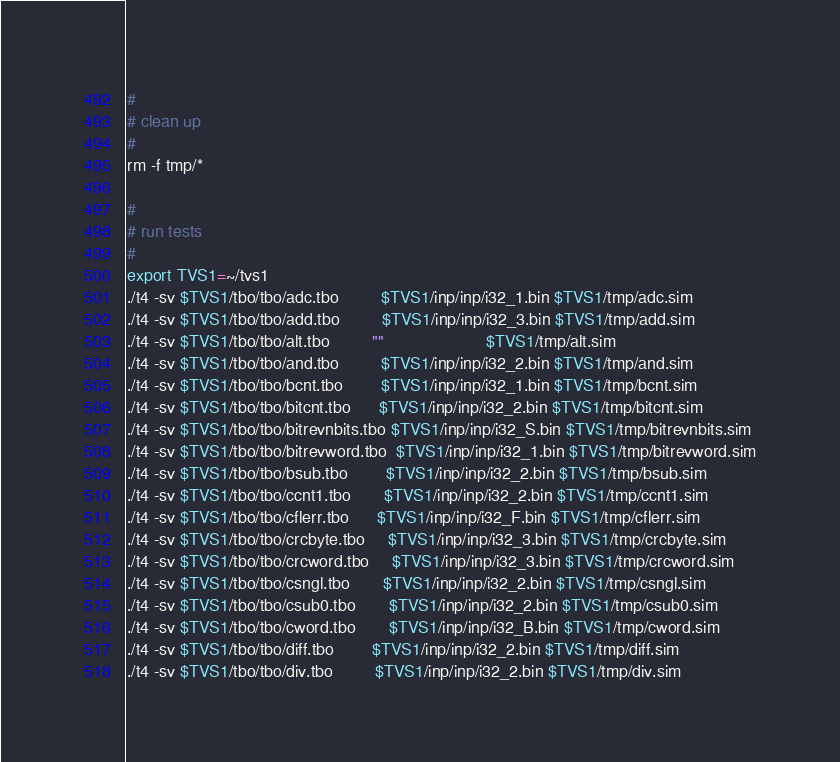<code> <loc_0><loc_0><loc_500><loc_500><_Bash_>#
# clean up
#
rm -f tmp/*

#
# run tests
#
export TVS1=~/tvs1
./t4 -sv $TVS1/tbo/tbo/adc.tbo         $TVS1/inp/inp/i32_1.bin $TVS1/tmp/adc.sim
./t4 -sv $TVS1/tbo/tbo/add.tbo         $TVS1/inp/inp/i32_3.bin $TVS1/tmp/add.sim
./t4 -sv $TVS1/tbo/tbo/alt.tbo         ""                      $TVS1/tmp/alt.sim
./t4 -sv $TVS1/tbo/tbo/and.tbo         $TVS1/inp/inp/i32_2.bin $TVS1/tmp/and.sim
./t4 -sv $TVS1/tbo/tbo/bcnt.tbo        $TVS1/inp/inp/i32_1.bin $TVS1/tmp/bcnt.sim
./t4 -sv $TVS1/tbo/tbo/bitcnt.tbo      $TVS1/inp/inp/i32_2.bin $TVS1/tmp/bitcnt.sim
./t4 -sv $TVS1/tbo/tbo/bitrevnbits.tbo $TVS1/inp/inp/i32_S.bin $TVS1/tmp/bitrevnbits.sim
./t4 -sv $TVS1/tbo/tbo/bitrevword.tbo  $TVS1/inp/inp/i32_1.bin $TVS1/tmp/bitrevword.sim
./t4 -sv $TVS1/tbo/tbo/bsub.tbo        $TVS1/inp/inp/i32_2.bin $TVS1/tmp/bsub.sim
./t4 -sv $TVS1/tbo/tbo/ccnt1.tbo       $TVS1/inp/inp/i32_2.bin $TVS1/tmp/ccnt1.sim
./t4 -sv $TVS1/tbo/tbo/cflerr.tbo      $TVS1/inp/inp/i32_F.bin $TVS1/tmp/cflerr.sim
./t4 -sv $TVS1/tbo/tbo/crcbyte.tbo     $TVS1/inp/inp/i32_3.bin $TVS1/tmp/crcbyte.sim
./t4 -sv $TVS1/tbo/tbo/crcword.tbo     $TVS1/inp/inp/i32_3.bin $TVS1/tmp/crcword.sim
./t4 -sv $TVS1/tbo/tbo/csngl.tbo       $TVS1/inp/inp/i32_2.bin $TVS1/tmp/csngl.sim
./t4 -sv $TVS1/tbo/tbo/csub0.tbo       $TVS1/inp/inp/i32_2.bin $TVS1/tmp/csub0.sim
./t4 -sv $TVS1/tbo/tbo/cword.tbo       $TVS1/inp/inp/i32_B.bin $TVS1/tmp/cword.sim
./t4 -sv $TVS1/tbo/tbo/diff.tbo        $TVS1/inp/inp/i32_2.bin $TVS1/tmp/diff.sim
./t4 -sv $TVS1/tbo/tbo/div.tbo         $TVS1/inp/inp/i32_2.bin $TVS1/tmp/div.sim</code> 